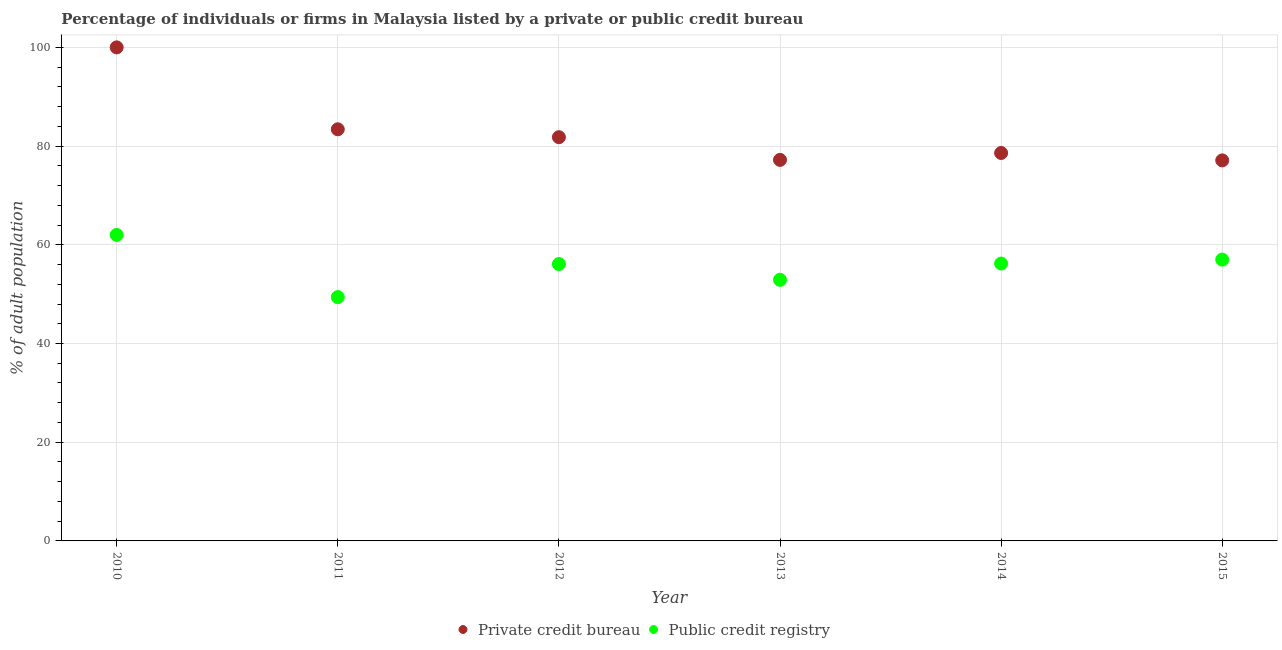How many different coloured dotlines are there?
Make the answer very short. 2. What is the percentage of firms listed by private credit bureau in 2011?
Your response must be concise. 83.4. Across all years, what is the maximum percentage of firms listed by public credit bureau?
Your answer should be compact. 62. Across all years, what is the minimum percentage of firms listed by public credit bureau?
Ensure brevity in your answer.  49.4. What is the total percentage of firms listed by private credit bureau in the graph?
Offer a terse response. 498.1. What is the difference between the percentage of firms listed by public credit bureau in 2011 and that in 2012?
Provide a succinct answer. -6.7. What is the difference between the percentage of firms listed by private credit bureau in 2014 and the percentage of firms listed by public credit bureau in 2012?
Ensure brevity in your answer.  22.5. What is the average percentage of firms listed by public credit bureau per year?
Ensure brevity in your answer.  55.6. In the year 2012, what is the difference between the percentage of firms listed by public credit bureau and percentage of firms listed by private credit bureau?
Give a very brief answer. -25.7. In how many years, is the percentage of firms listed by private credit bureau greater than 88 %?
Make the answer very short. 1. What is the ratio of the percentage of firms listed by private credit bureau in 2011 to that in 2012?
Provide a short and direct response. 1.02. Is the percentage of firms listed by public credit bureau in 2012 less than that in 2013?
Your answer should be very brief. No. What is the difference between the highest and the second highest percentage of firms listed by private credit bureau?
Your answer should be compact. 16.6. What is the difference between the highest and the lowest percentage of firms listed by private credit bureau?
Offer a very short reply. 22.9. In how many years, is the percentage of firms listed by public credit bureau greater than the average percentage of firms listed by public credit bureau taken over all years?
Make the answer very short. 4. Is the sum of the percentage of firms listed by private credit bureau in 2014 and 2015 greater than the maximum percentage of firms listed by public credit bureau across all years?
Make the answer very short. Yes. How many years are there in the graph?
Your answer should be compact. 6. Are the values on the major ticks of Y-axis written in scientific E-notation?
Offer a very short reply. No. Does the graph contain any zero values?
Ensure brevity in your answer.  No. Does the graph contain grids?
Provide a short and direct response. Yes. How are the legend labels stacked?
Provide a succinct answer. Horizontal. What is the title of the graph?
Give a very brief answer. Percentage of individuals or firms in Malaysia listed by a private or public credit bureau. Does "Electricity" appear as one of the legend labels in the graph?
Keep it short and to the point. No. What is the label or title of the X-axis?
Offer a terse response. Year. What is the label or title of the Y-axis?
Your answer should be very brief. % of adult population. What is the % of adult population of Private credit bureau in 2011?
Make the answer very short. 83.4. What is the % of adult population in Public credit registry in 2011?
Provide a short and direct response. 49.4. What is the % of adult population of Private credit bureau in 2012?
Provide a succinct answer. 81.8. What is the % of adult population in Public credit registry in 2012?
Provide a short and direct response. 56.1. What is the % of adult population of Private credit bureau in 2013?
Ensure brevity in your answer.  77.2. What is the % of adult population in Public credit registry in 2013?
Offer a very short reply. 52.9. What is the % of adult population of Private credit bureau in 2014?
Offer a very short reply. 78.6. What is the % of adult population in Public credit registry in 2014?
Your response must be concise. 56.2. What is the % of adult population of Private credit bureau in 2015?
Offer a terse response. 77.1. What is the % of adult population of Public credit registry in 2015?
Your answer should be compact. 57. Across all years, what is the maximum % of adult population of Private credit bureau?
Provide a short and direct response. 100. Across all years, what is the minimum % of adult population of Private credit bureau?
Ensure brevity in your answer.  77.1. Across all years, what is the minimum % of adult population of Public credit registry?
Offer a terse response. 49.4. What is the total % of adult population in Private credit bureau in the graph?
Your response must be concise. 498.1. What is the total % of adult population in Public credit registry in the graph?
Your response must be concise. 333.6. What is the difference between the % of adult population in Public credit registry in 2010 and that in 2011?
Make the answer very short. 12.6. What is the difference between the % of adult population of Private credit bureau in 2010 and that in 2012?
Provide a succinct answer. 18.2. What is the difference between the % of adult population of Public credit registry in 2010 and that in 2012?
Your answer should be very brief. 5.9. What is the difference between the % of adult population in Private credit bureau in 2010 and that in 2013?
Ensure brevity in your answer.  22.8. What is the difference between the % of adult population of Public credit registry in 2010 and that in 2013?
Ensure brevity in your answer.  9.1. What is the difference between the % of adult population in Private credit bureau in 2010 and that in 2014?
Provide a succinct answer. 21.4. What is the difference between the % of adult population of Private credit bureau in 2010 and that in 2015?
Offer a very short reply. 22.9. What is the difference between the % of adult population in Public credit registry in 2010 and that in 2015?
Keep it short and to the point. 5. What is the difference between the % of adult population in Public credit registry in 2011 and that in 2012?
Ensure brevity in your answer.  -6.7. What is the difference between the % of adult population in Private credit bureau in 2011 and that in 2014?
Ensure brevity in your answer.  4.8. What is the difference between the % of adult population of Public credit registry in 2011 and that in 2015?
Provide a succinct answer. -7.6. What is the difference between the % of adult population in Private credit bureau in 2012 and that in 2013?
Ensure brevity in your answer.  4.6. What is the difference between the % of adult population of Public credit registry in 2012 and that in 2013?
Your response must be concise. 3.2. What is the difference between the % of adult population of Private credit bureau in 2012 and that in 2015?
Offer a terse response. 4.7. What is the difference between the % of adult population of Public credit registry in 2012 and that in 2015?
Provide a succinct answer. -0.9. What is the difference between the % of adult population in Private credit bureau in 2013 and that in 2015?
Offer a very short reply. 0.1. What is the difference between the % of adult population of Private credit bureau in 2014 and that in 2015?
Your answer should be compact. 1.5. What is the difference between the % of adult population in Private credit bureau in 2010 and the % of adult population in Public credit registry in 2011?
Make the answer very short. 50.6. What is the difference between the % of adult population of Private credit bureau in 2010 and the % of adult population of Public credit registry in 2012?
Offer a terse response. 43.9. What is the difference between the % of adult population in Private credit bureau in 2010 and the % of adult population in Public credit registry in 2013?
Provide a succinct answer. 47.1. What is the difference between the % of adult population in Private credit bureau in 2010 and the % of adult population in Public credit registry in 2014?
Give a very brief answer. 43.8. What is the difference between the % of adult population in Private credit bureau in 2010 and the % of adult population in Public credit registry in 2015?
Your response must be concise. 43. What is the difference between the % of adult population in Private credit bureau in 2011 and the % of adult population in Public credit registry in 2012?
Your answer should be compact. 27.3. What is the difference between the % of adult population of Private credit bureau in 2011 and the % of adult population of Public credit registry in 2013?
Give a very brief answer. 30.5. What is the difference between the % of adult population of Private credit bureau in 2011 and the % of adult population of Public credit registry in 2014?
Make the answer very short. 27.2. What is the difference between the % of adult population of Private credit bureau in 2011 and the % of adult population of Public credit registry in 2015?
Make the answer very short. 26.4. What is the difference between the % of adult population in Private credit bureau in 2012 and the % of adult population in Public credit registry in 2013?
Provide a succinct answer. 28.9. What is the difference between the % of adult population of Private credit bureau in 2012 and the % of adult population of Public credit registry in 2014?
Provide a succinct answer. 25.6. What is the difference between the % of adult population in Private credit bureau in 2012 and the % of adult population in Public credit registry in 2015?
Provide a succinct answer. 24.8. What is the difference between the % of adult population of Private credit bureau in 2013 and the % of adult population of Public credit registry in 2014?
Provide a short and direct response. 21. What is the difference between the % of adult population of Private credit bureau in 2013 and the % of adult population of Public credit registry in 2015?
Your answer should be very brief. 20.2. What is the difference between the % of adult population in Private credit bureau in 2014 and the % of adult population in Public credit registry in 2015?
Provide a succinct answer. 21.6. What is the average % of adult population of Private credit bureau per year?
Provide a short and direct response. 83.02. What is the average % of adult population in Public credit registry per year?
Your answer should be compact. 55.6. In the year 2010, what is the difference between the % of adult population in Private credit bureau and % of adult population in Public credit registry?
Your answer should be compact. 38. In the year 2011, what is the difference between the % of adult population in Private credit bureau and % of adult population in Public credit registry?
Your response must be concise. 34. In the year 2012, what is the difference between the % of adult population of Private credit bureau and % of adult population of Public credit registry?
Make the answer very short. 25.7. In the year 2013, what is the difference between the % of adult population of Private credit bureau and % of adult population of Public credit registry?
Ensure brevity in your answer.  24.3. In the year 2014, what is the difference between the % of adult population of Private credit bureau and % of adult population of Public credit registry?
Ensure brevity in your answer.  22.4. In the year 2015, what is the difference between the % of adult population in Private credit bureau and % of adult population in Public credit registry?
Make the answer very short. 20.1. What is the ratio of the % of adult population of Private credit bureau in 2010 to that in 2011?
Offer a very short reply. 1.2. What is the ratio of the % of adult population of Public credit registry in 2010 to that in 2011?
Keep it short and to the point. 1.26. What is the ratio of the % of adult population of Private credit bureau in 2010 to that in 2012?
Provide a succinct answer. 1.22. What is the ratio of the % of adult population in Public credit registry in 2010 to that in 2012?
Your answer should be compact. 1.11. What is the ratio of the % of adult population of Private credit bureau in 2010 to that in 2013?
Provide a short and direct response. 1.3. What is the ratio of the % of adult population in Public credit registry in 2010 to that in 2013?
Offer a very short reply. 1.17. What is the ratio of the % of adult population in Private credit bureau in 2010 to that in 2014?
Provide a short and direct response. 1.27. What is the ratio of the % of adult population in Public credit registry in 2010 to that in 2014?
Provide a short and direct response. 1.1. What is the ratio of the % of adult population in Private credit bureau in 2010 to that in 2015?
Offer a very short reply. 1.3. What is the ratio of the % of adult population of Public credit registry in 2010 to that in 2015?
Keep it short and to the point. 1.09. What is the ratio of the % of adult population of Private credit bureau in 2011 to that in 2012?
Give a very brief answer. 1.02. What is the ratio of the % of adult population in Public credit registry in 2011 to that in 2012?
Keep it short and to the point. 0.88. What is the ratio of the % of adult population in Private credit bureau in 2011 to that in 2013?
Provide a succinct answer. 1.08. What is the ratio of the % of adult population in Public credit registry in 2011 to that in 2013?
Your answer should be compact. 0.93. What is the ratio of the % of adult population of Private credit bureau in 2011 to that in 2014?
Give a very brief answer. 1.06. What is the ratio of the % of adult population of Public credit registry in 2011 to that in 2014?
Make the answer very short. 0.88. What is the ratio of the % of adult population of Private credit bureau in 2011 to that in 2015?
Give a very brief answer. 1.08. What is the ratio of the % of adult population of Public credit registry in 2011 to that in 2015?
Offer a terse response. 0.87. What is the ratio of the % of adult population of Private credit bureau in 2012 to that in 2013?
Provide a succinct answer. 1.06. What is the ratio of the % of adult population in Public credit registry in 2012 to that in 2013?
Provide a short and direct response. 1.06. What is the ratio of the % of adult population of Private credit bureau in 2012 to that in 2014?
Make the answer very short. 1.04. What is the ratio of the % of adult population in Public credit registry in 2012 to that in 2014?
Provide a succinct answer. 1. What is the ratio of the % of adult population of Private credit bureau in 2012 to that in 2015?
Your response must be concise. 1.06. What is the ratio of the % of adult population in Public credit registry in 2012 to that in 2015?
Ensure brevity in your answer.  0.98. What is the ratio of the % of adult population of Private credit bureau in 2013 to that in 2014?
Keep it short and to the point. 0.98. What is the ratio of the % of adult population of Public credit registry in 2013 to that in 2014?
Offer a terse response. 0.94. What is the ratio of the % of adult population of Private credit bureau in 2013 to that in 2015?
Your answer should be compact. 1. What is the ratio of the % of adult population of Public credit registry in 2013 to that in 2015?
Give a very brief answer. 0.93. What is the ratio of the % of adult population in Private credit bureau in 2014 to that in 2015?
Ensure brevity in your answer.  1.02. What is the ratio of the % of adult population in Public credit registry in 2014 to that in 2015?
Ensure brevity in your answer.  0.99. What is the difference between the highest and the lowest % of adult population in Private credit bureau?
Your response must be concise. 22.9. 